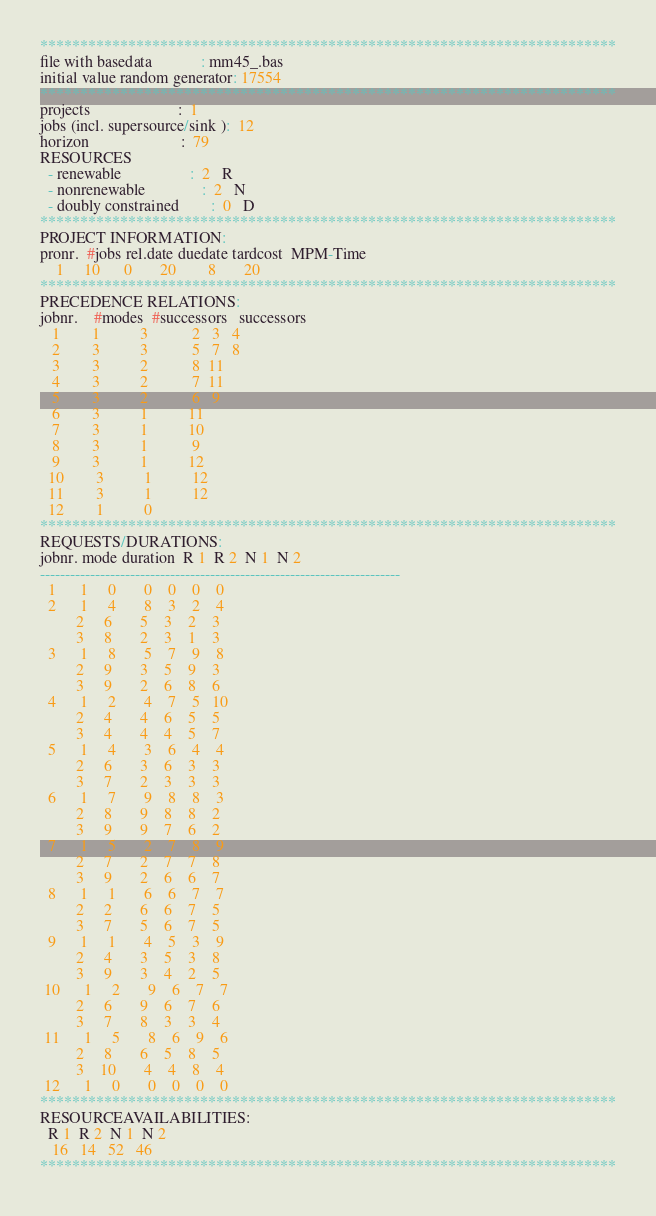<code> <loc_0><loc_0><loc_500><loc_500><_ObjectiveC_>************************************************************************
file with basedata            : mm45_.bas
initial value random generator: 17554
************************************************************************
projects                      :  1
jobs (incl. supersource/sink ):  12
horizon                       :  79
RESOURCES
  - renewable                 :  2   R
  - nonrenewable              :  2   N
  - doubly constrained        :  0   D
************************************************************************
PROJECT INFORMATION:
pronr.  #jobs rel.date duedate tardcost  MPM-Time
    1     10      0       20        8       20
************************************************************************
PRECEDENCE RELATIONS:
jobnr.    #modes  #successors   successors
   1        1          3           2   3   4
   2        3          3           5   7   8
   3        3          2           8  11
   4        3          2           7  11
   5        3          2           6   9
   6        3          1          11
   7        3          1          10
   8        3          1           9
   9        3          1          12
  10        3          1          12
  11        3          1          12
  12        1          0        
************************************************************************
REQUESTS/DURATIONS:
jobnr. mode duration  R 1  R 2  N 1  N 2
------------------------------------------------------------------------
  1      1     0       0    0    0    0
  2      1     4       8    3    2    4
         2     6       5    3    2    3
         3     8       2    3    1    3
  3      1     8       5    7    9    8
         2     9       3    5    9    3
         3     9       2    6    8    6
  4      1     2       4    7    5   10
         2     4       4    6    5    5
         3     4       4    4    5    7
  5      1     4       3    6    4    4
         2     6       3    6    3    3
         3     7       2    3    3    3
  6      1     7       9    8    8    3
         2     8       9    8    8    2
         3     9       9    7    6    2
  7      1     5       2    7    8    9
         2     7       2    7    7    8
         3     9       2    6    6    7
  8      1     1       6    6    7    7
         2     2       6    6    7    5
         3     7       5    6    7    5
  9      1     1       4    5    3    9
         2     4       3    5    3    8
         3     9       3    4    2    5
 10      1     2       9    6    7    7
         2     6       9    6    7    6
         3     7       8    3    3    4
 11      1     5       8    6    9    6
         2     8       6    5    8    5
         3    10       4    4    8    4
 12      1     0       0    0    0    0
************************************************************************
RESOURCEAVAILABILITIES:
  R 1  R 2  N 1  N 2
   16   14   52   46
************************************************************************
</code> 